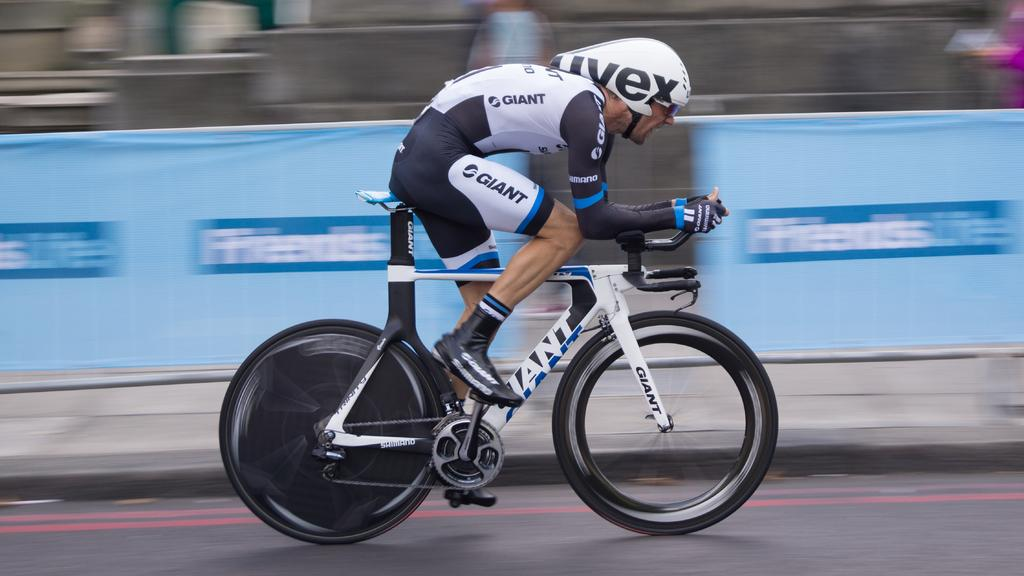<image>
Present a compact description of the photo's key features. A man wearing a UVEX helmet races down the track on his bike 